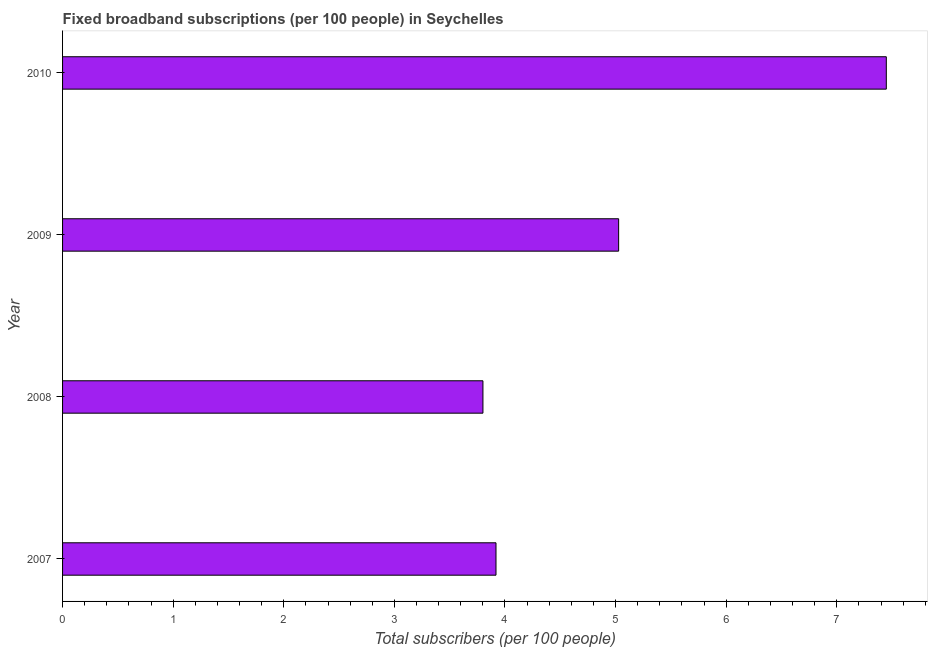Does the graph contain any zero values?
Your answer should be very brief. No. What is the title of the graph?
Your response must be concise. Fixed broadband subscriptions (per 100 people) in Seychelles. What is the label or title of the X-axis?
Your answer should be compact. Total subscribers (per 100 people). What is the label or title of the Y-axis?
Keep it short and to the point. Year. What is the total number of fixed broadband subscriptions in 2010?
Give a very brief answer. 7.45. Across all years, what is the maximum total number of fixed broadband subscriptions?
Keep it short and to the point. 7.45. Across all years, what is the minimum total number of fixed broadband subscriptions?
Offer a very short reply. 3.8. In which year was the total number of fixed broadband subscriptions minimum?
Give a very brief answer. 2008. What is the sum of the total number of fixed broadband subscriptions?
Offer a very short reply. 20.2. What is the difference between the total number of fixed broadband subscriptions in 2007 and 2010?
Your response must be concise. -3.53. What is the average total number of fixed broadband subscriptions per year?
Provide a succinct answer. 5.05. What is the median total number of fixed broadband subscriptions?
Offer a very short reply. 4.47. In how many years, is the total number of fixed broadband subscriptions greater than 0.2 ?
Provide a succinct answer. 4. What is the ratio of the total number of fixed broadband subscriptions in 2007 to that in 2008?
Offer a terse response. 1.03. Is the difference between the total number of fixed broadband subscriptions in 2007 and 2010 greater than the difference between any two years?
Your answer should be compact. No. What is the difference between the highest and the second highest total number of fixed broadband subscriptions?
Your answer should be very brief. 2.42. Is the sum of the total number of fixed broadband subscriptions in 2008 and 2010 greater than the maximum total number of fixed broadband subscriptions across all years?
Provide a succinct answer. Yes. What is the difference between the highest and the lowest total number of fixed broadband subscriptions?
Your response must be concise. 3.65. Are all the bars in the graph horizontal?
Make the answer very short. Yes. What is the Total subscribers (per 100 people) of 2007?
Keep it short and to the point. 3.92. What is the Total subscribers (per 100 people) in 2008?
Offer a very short reply. 3.8. What is the Total subscribers (per 100 people) of 2009?
Your answer should be compact. 5.03. What is the Total subscribers (per 100 people) of 2010?
Your response must be concise. 7.45. What is the difference between the Total subscribers (per 100 people) in 2007 and 2008?
Offer a very short reply. 0.12. What is the difference between the Total subscribers (per 100 people) in 2007 and 2009?
Your answer should be compact. -1.11. What is the difference between the Total subscribers (per 100 people) in 2007 and 2010?
Keep it short and to the point. -3.53. What is the difference between the Total subscribers (per 100 people) in 2008 and 2009?
Offer a terse response. -1.23. What is the difference between the Total subscribers (per 100 people) in 2008 and 2010?
Your answer should be compact. -3.65. What is the difference between the Total subscribers (per 100 people) in 2009 and 2010?
Give a very brief answer. -2.42. What is the ratio of the Total subscribers (per 100 people) in 2007 to that in 2008?
Your answer should be very brief. 1.03. What is the ratio of the Total subscribers (per 100 people) in 2007 to that in 2009?
Give a very brief answer. 0.78. What is the ratio of the Total subscribers (per 100 people) in 2007 to that in 2010?
Keep it short and to the point. 0.53. What is the ratio of the Total subscribers (per 100 people) in 2008 to that in 2009?
Make the answer very short. 0.76. What is the ratio of the Total subscribers (per 100 people) in 2008 to that in 2010?
Ensure brevity in your answer.  0.51. What is the ratio of the Total subscribers (per 100 people) in 2009 to that in 2010?
Give a very brief answer. 0.68. 